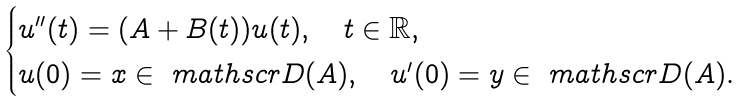Convert formula to latex. <formula><loc_0><loc_0><loc_500><loc_500>\begin{cases} u ^ { \prime \prime } ( t ) = ( A + B ( t ) ) u ( t ) , \quad t \in \mathbb { R } , \\ u ( 0 ) = x \in \ m a t h s c r { D } ( A ) , \quad u ^ { \prime } ( 0 ) = y \in \ m a t h s c r { D } ( A ) . \end{cases}</formula> 